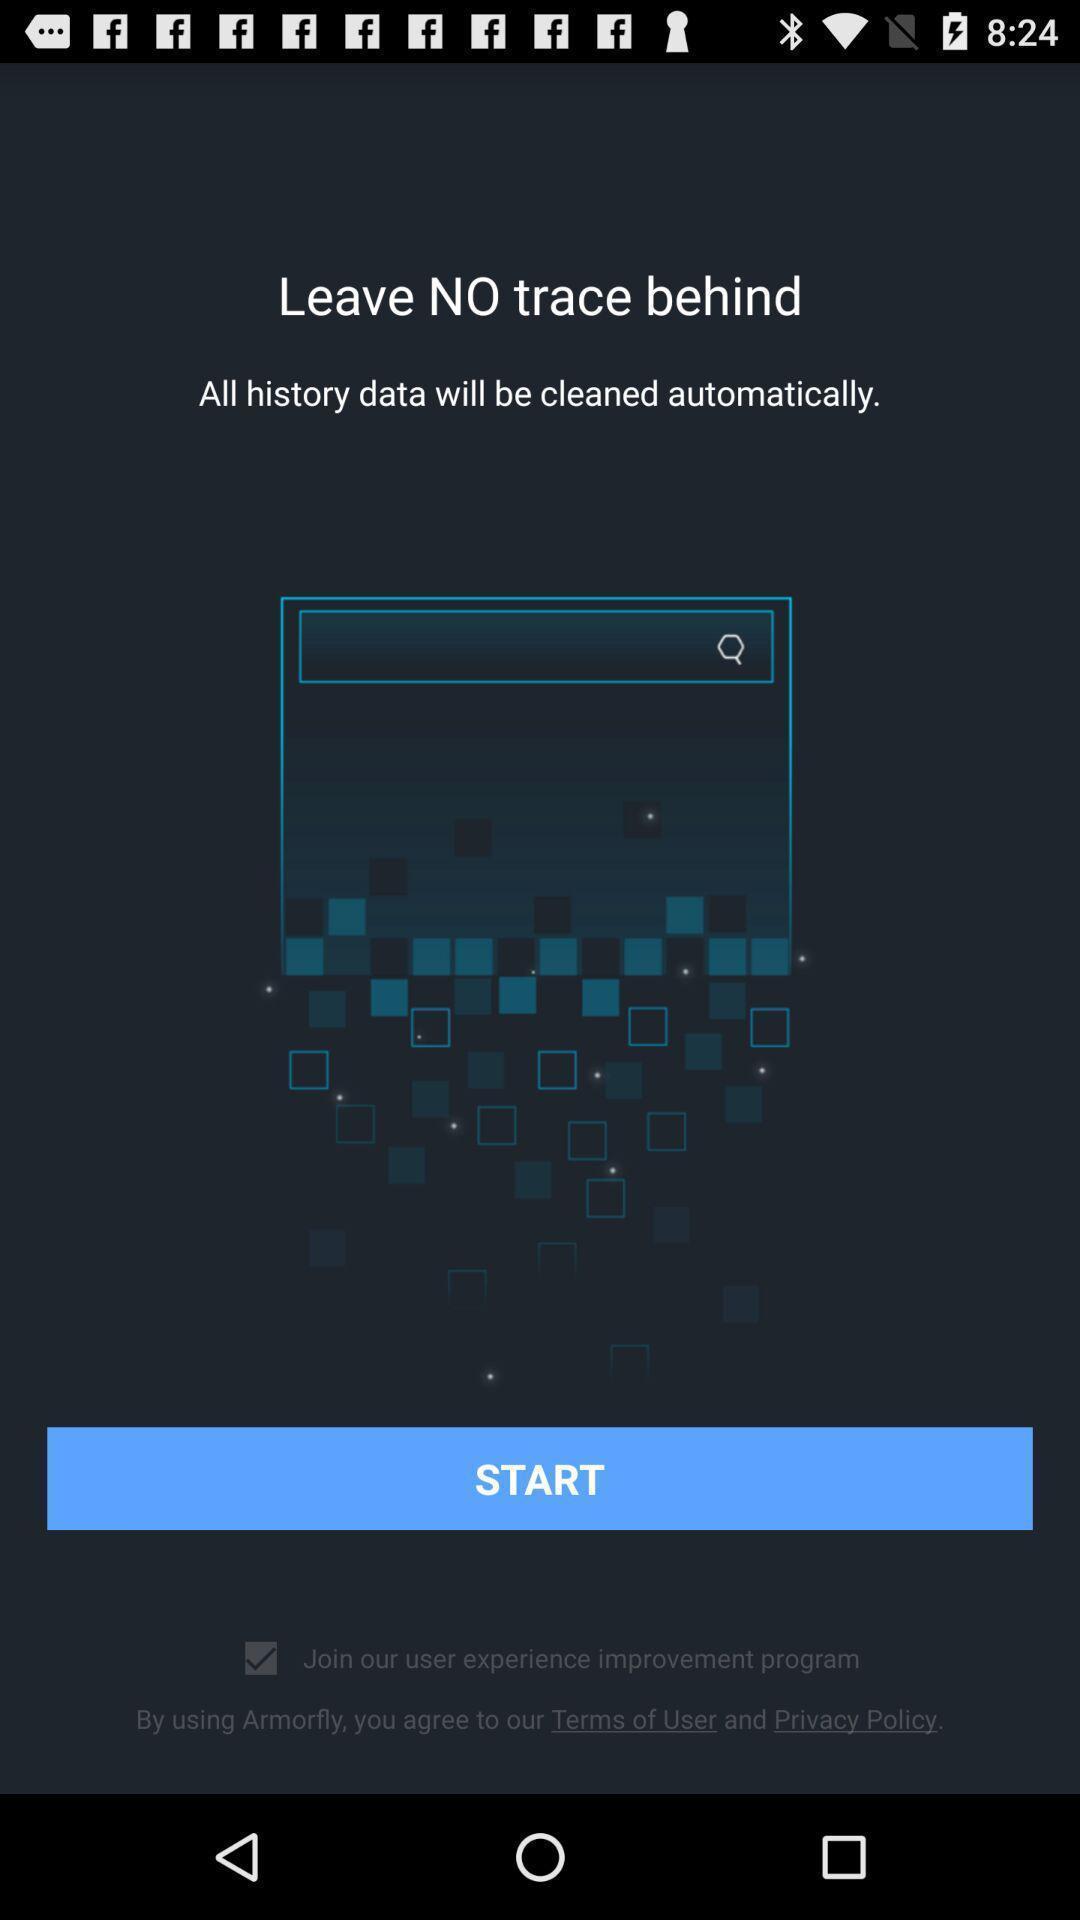Describe the visual elements of this screenshot. Welocome page for a browsing app. 